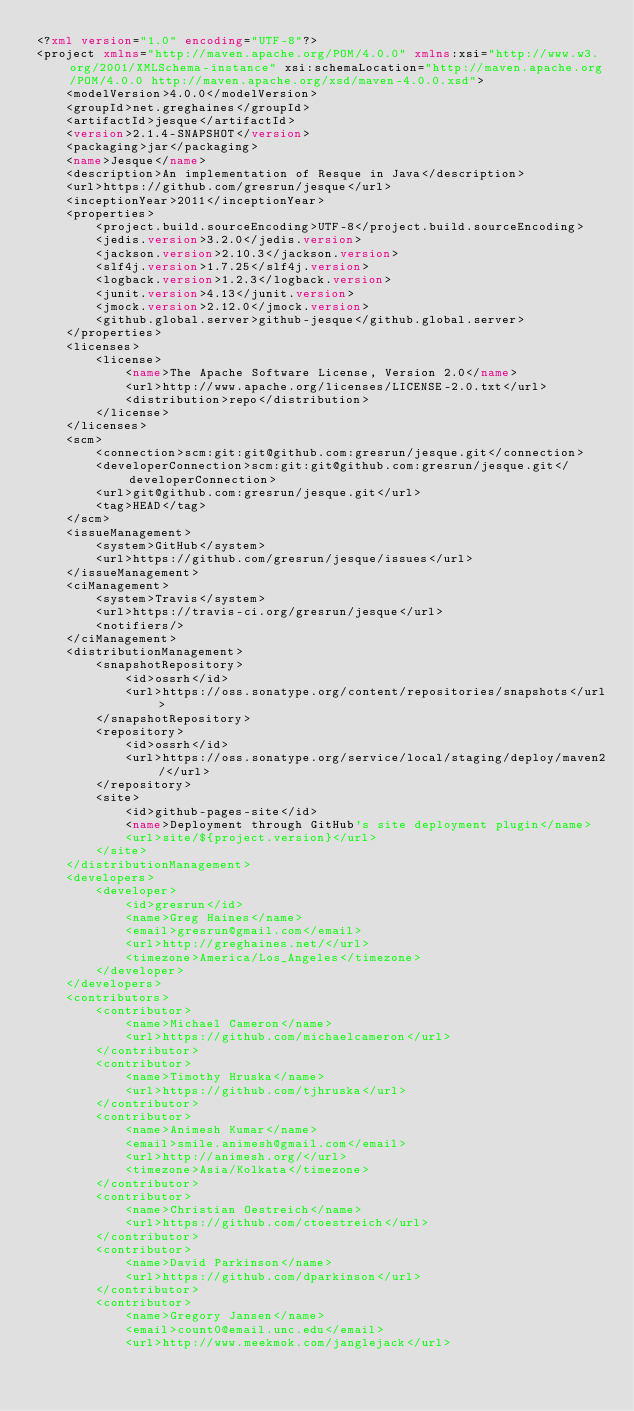Convert code to text. <code><loc_0><loc_0><loc_500><loc_500><_XML_><?xml version="1.0" encoding="UTF-8"?>
<project xmlns="http://maven.apache.org/POM/4.0.0" xmlns:xsi="http://www.w3.org/2001/XMLSchema-instance" xsi:schemaLocation="http://maven.apache.org/POM/4.0.0 http://maven.apache.org/xsd/maven-4.0.0.xsd">
    <modelVersion>4.0.0</modelVersion>
    <groupId>net.greghaines</groupId>
    <artifactId>jesque</artifactId>
    <version>2.1.4-SNAPSHOT</version>
    <packaging>jar</packaging>
    <name>Jesque</name>
    <description>An implementation of Resque in Java</description>
    <url>https://github.com/gresrun/jesque</url>
    <inceptionYear>2011</inceptionYear>
    <properties>
        <project.build.sourceEncoding>UTF-8</project.build.sourceEncoding>
        <jedis.version>3.2.0</jedis.version>
        <jackson.version>2.10.3</jackson.version>
        <slf4j.version>1.7.25</slf4j.version>
        <logback.version>1.2.3</logback.version>
        <junit.version>4.13</junit.version>
        <jmock.version>2.12.0</jmock.version>
        <github.global.server>github-jesque</github.global.server>
    </properties>
    <licenses>
        <license>
            <name>The Apache Software License, Version 2.0</name>
            <url>http://www.apache.org/licenses/LICENSE-2.0.txt</url>
            <distribution>repo</distribution>
        </license>
    </licenses>
    <scm>
        <connection>scm:git:git@github.com:gresrun/jesque.git</connection>
        <developerConnection>scm:git:git@github.com:gresrun/jesque.git</developerConnection>
        <url>git@github.com:gresrun/jesque.git</url>
        <tag>HEAD</tag>
    </scm>
    <issueManagement>
        <system>GitHub</system>
        <url>https://github.com/gresrun/jesque/issues</url>
    </issueManagement>
    <ciManagement>
        <system>Travis</system>
        <url>https://travis-ci.org/gresrun/jesque</url>
        <notifiers/>
    </ciManagement>
    <distributionManagement>
        <snapshotRepository>
            <id>ossrh</id>
            <url>https://oss.sonatype.org/content/repositories/snapshots</url>
        </snapshotRepository>
        <repository>
            <id>ossrh</id>
            <url>https://oss.sonatype.org/service/local/staging/deploy/maven2/</url>
        </repository>
        <site>
            <id>github-pages-site</id>
            <name>Deployment through GitHub's site deployment plugin</name>
            <url>site/${project.version}</url>
        </site>
    </distributionManagement>
    <developers>
        <developer>
            <id>gresrun</id>
            <name>Greg Haines</name>
            <email>gresrun@gmail.com</email>
            <url>http://greghaines.net/</url>
            <timezone>America/Los_Angeles</timezone>
        </developer>
    </developers>
    <contributors>
        <contributor>
            <name>Michael Cameron</name>
            <url>https://github.com/michaelcameron</url>
        </contributor>
        <contributor>
            <name>Timothy Hruska</name>
            <url>https://github.com/tjhruska</url>
        </contributor>
        <contributor>
            <name>Animesh Kumar</name>
            <email>smile.animesh@gmail.com</email>
            <url>http://animesh.org/</url>
            <timezone>Asia/Kolkata</timezone>
        </contributor>
        <contributor>
            <name>Christian Oestreich</name>
            <url>https://github.com/ctoestreich</url>
        </contributor>
        <contributor>
            <name>David Parkinson</name>
            <url>https://github.com/dparkinson</url>
        </contributor>
        <contributor>
            <name>Gregory Jansen</name>
            <email>count0@email.unc.edu</email>
            <url>http://www.meekmok.com/janglejack</url></code> 